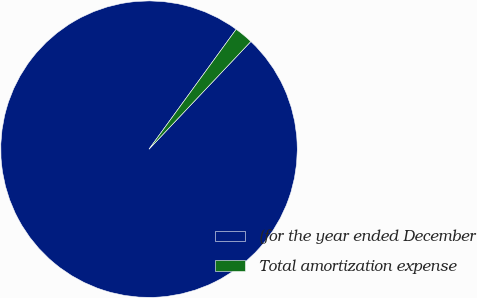Convert chart to OTSL. <chart><loc_0><loc_0><loc_500><loc_500><pie_chart><fcel>(for the year ended December<fcel>Total amortization expense<nl><fcel>97.95%<fcel>2.05%<nl></chart> 